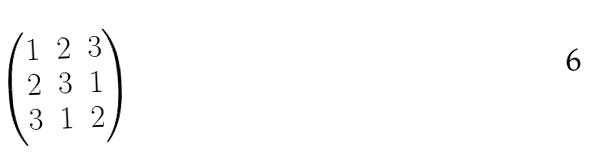<formula> <loc_0><loc_0><loc_500><loc_500>\begin{pmatrix} 1 & 2 & 3 \\ 2 & 3 & 1 \\ 3 & 1 & 2 \end{pmatrix}</formula> 